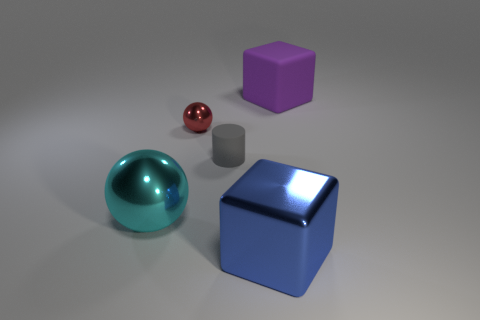How many other objects are there of the same shape as the red thing?
Provide a short and direct response. 1. Is the number of metal blocks greater than the number of big gray rubber balls?
Your response must be concise. Yes. How big is the shiny ball on the right side of the big object on the left side of the large cube in front of the small matte thing?
Provide a short and direct response. Small. There is a metallic sphere in front of the small metallic sphere; what size is it?
Ensure brevity in your answer.  Large. How many things are small shiny cylinders or large things that are behind the red thing?
Give a very brief answer. 1. How many other things are there of the same size as the gray cylinder?
Ensure brevity in your answer.  1. What is the material of the other object that is the same shape as the purple matte thing?
Your answer should be very brief. Metal. Are there more cyan spheres that are left of the metal block than blue rubber blocks?
Keep it short and to the point. Yes. What is the shape of the blue object that is the same material as the red ball?
Your response must be concise. Cube. Are the tiny thing that is in front of the tiny metal object and the large sphere made of the same material?
Give a very brief answer. No. 